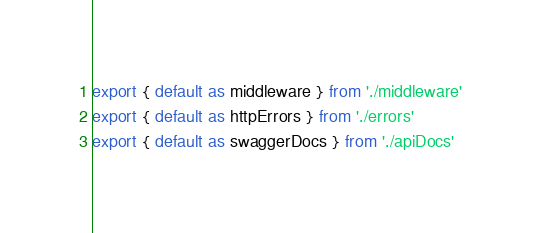<code> <loc_0><loc_0><loc_500><loc_500><_TypeScript_>export { default as middleware } from './middleware'
export { default as httpErrors } from './errors'
export { default as swaggerDocs } from './apiDocs'
</code> 